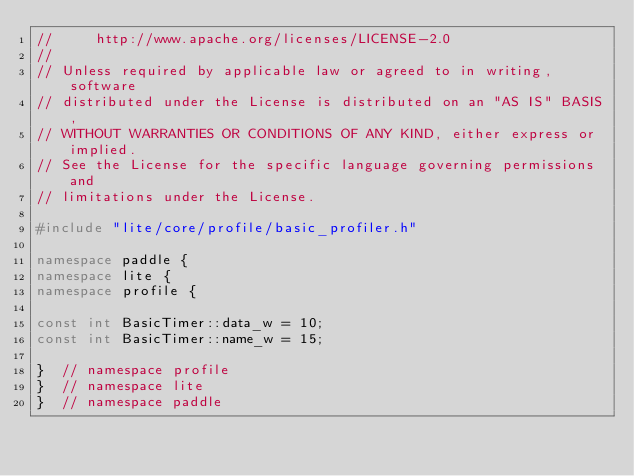<code> <loc_0><loc_0><loc_500><loc_500><_C++_>//     http://www.apache.org/licenses/LICENSE-2.0
//
// Unless required by applicable law or agreed to in writing, software
// distributed under the License is distributed on an "AS IS" BASIS,
// WITHOUT WARRANTIES OR CONDITIONS OF ANY KIND, either express or implied.
// See the License for the specific language governing permissions and
// limitations under the License.

#include "lite/core/profile/basic_profiler.h"

namespace paddle {
namespace lite {
namespace profile {

const int BasicTimer::data_w = 10;
const int BasicTimer::name_w = 15;

}  // namespace profile
}  // namespace lite
}  // namespace paddle
</code> 